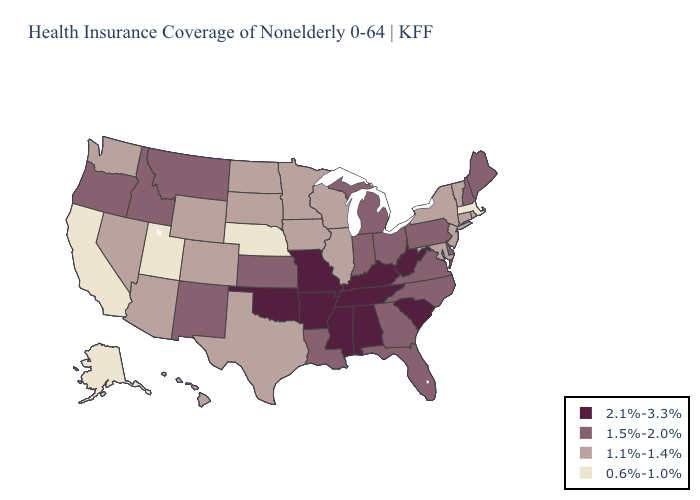What is the value of Mississippi?
Answer briefly. 2.1%-3.3%. Is the legend a continuous bar?
Keep it brief. No. Among the states that border Iowa , which have the highest value?
Give a very brief answer. Missouri. Does Delaware have the lowest value in the South?
Keep it brief. No. Which states have the highest value in the USA?
Quick response, please. Alabama, Arkansas, Kentucky, Mississippi, Missouri, Oklahoma, South Carolina, Tennessee, West Virginia. What is the value of New Jersey?
Concise answer only. 1.1%-1.4%. Does Michigan have the lowest value in the MidWest?
Write a very short answer. No. What is the highest value in states that border Florida?
Be succinct. 2.1%-3.3%. Name the states that have a value in the range 1.5%-2.0%?
Be succinct. Delaware, Florida, Georgia, Idaho, Indiana, Kansas, Louisiana, Maine, Michigan, Montana, New Hampshire, New Mexico, North Carolina, Ohio, Oregon, Pennsylvania, Virginia. Among the states that border Utah , does Arizona have the lowest value?
Short answer required. Yes. What is the value of South Dakota?
Keep it brief. 1.1%-1.4%. Name the states that have a value in the range 1.5%-2.0%?
Be succinct. Delaware, Florida, Georgia, Idaho, Indiana, Kansas, Louisiana, Maine, Michigan, Montana, New Hampshire, New Mexico, North Carolina, Ohio, Oregon, Pennsylvania, Virginia. Name the states that have a value in the range 1.1%-1.4%?
Quick response, please. Arizona, Colorado, Connecticut, Hawaii, Illinois, Iowa, Maryland, Minnesota, Nevada, New Jersey, New York, North Dakota, Rhode Island, South Dakota, Texas, Vermont, Washington, Wisconsin, Wyoming. Name the states that have a value in the range 2.1%-3.3%?
Answer briefly. Alabama, Arkansas, Kentucky, Mississippi, Missouri, Oklahoma, South Carolina, Tennessee, West Virginia. Name the states that have a value in the range 1.5%-2.0%?
Keep it brief. Delaware, Florida, Georgia, Idaho, Indiana, Kansas, Louisiana, Maine, Michigan, Montana, New Hampshire, New Mexico, North Carolina, Ohio, Oregon, Pennsylvania, Virginia. 